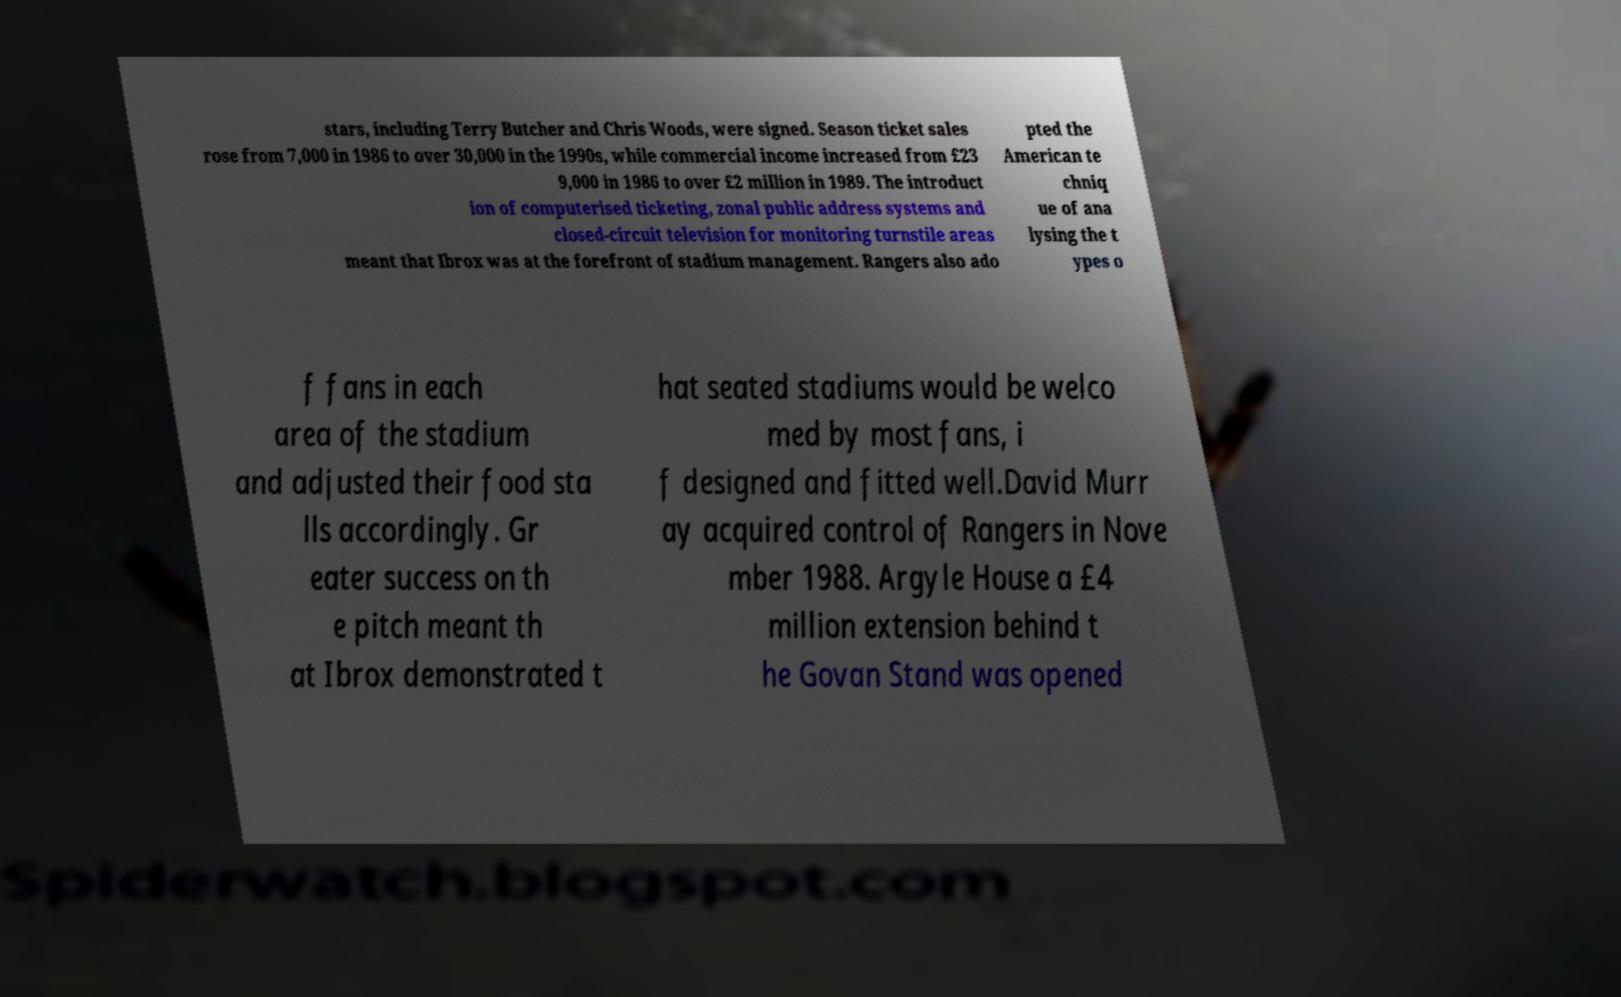Please identify and transcribe the text found in this image. stars, including Terry Butcher and Chris Woods, were signed. Season ticket sales rose from 7,000 in 1986 to over 30,000 in the 1990s, while commercial income increased from £23 9,000 in 1986 to over £2 million in 1989. The introduct ion of computerised ticketing, zonal public address systems and closed-circuit television for monitoring turnstile areas meant that Ibrox was at the forefront of stadium management. Rangers also ado pted the American te chniq ue of ana lysing the t ypes o f fans in each area of the stadium and adjusted their food sta lls accordingly. Gr eater success on th e pitch meant th at Ibrox demonstrated t hat seated stadiums would be welco med by most fans, i f designed and fitted well.David Murr ay acquired control of Rangers in Nove mber 1988. Argyle House a £4 million extension behind t he Govan Stand was opened 